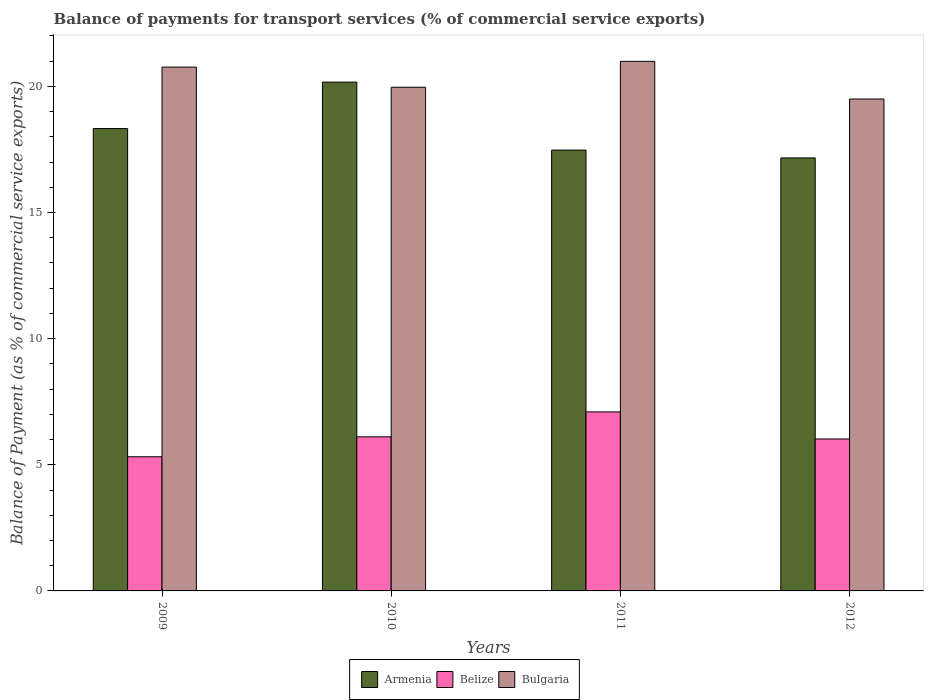How many groups of bars are there?
Provide a succinct answer. 4. What is the label of the 2nd group of bars from the left?
Provide a succinct answer. 2010. In how many cases, is the number of bars for a given year not equal to the number of legend labels?
Your response must be concise. 0. What is the balance of payments for transport services in Armenia in 2012?
Your answer should be compact. 17.16. Across all years, what is the maximum balance of payments for transport services in Bulgaria?
Your answer should be compact. 20.99. Across all years, what is the minimum balance of payments for transport services in Belize?
Make the answer very short. 5.32. In which year was the balance of payments for transport services in Bulgaria minimum?
Your answer should be compact. 2012. What is the total balance of payments for transport services in Bulgaria in the graph?
Your response must be concise. 81.22. What is the difference between the balance of payments for transport services in Armenia in 2011 and that in 2012?
Make the answer very short. 0.31. What is the difference between the balance of payments for transport services in Bulgaria in 2009 and the balance of payments for transport services in Armenia in 2012?
Provide a succinct answer. 3.6. What is the average balance of payments for transport services in Armenia per year?
Offer a terse response. 18.28. In the year 2012, what is the difference between the balance of payments for transport services in Belize and balance of payments for transport services in Armenia?
Give a very brief answer. -11.14. What is the ratio of the balance of payments for transport services in Armenia in 2009 to that in 2011?
Offer a very short reply. 1.05. Is the balance of payments for transport services in Belize in 2009 less than that in 2010?
Your answer should be compact. Yes. What is the difference between the highest and the second highest balance of payments for transport services in Bulgaria?
Provide a succinct answer. 0.23. What is the difference between the highest and the lowest balance of payments for transport services in Armenia?
Ensure brevity in your answer.  3.01. In how many years, is the balance of payments for transport services in Armenia greater than the average balance of payments for transport services in Armenia taken over all years?
Offer a terse response. 2. Is the sum of the balance of payments for transport services in Bulgaria in 2010 and 2011 greater than the maximum balance of payments for transport services in Armenia across all years?
Your answer should be very brief. Yes. What does the 1st bar from the left in 2011 represents?
Offer a terse response. Armenia. What does the 3rd bar from the right in 2010 represents?
Make the answer very short. Armenia. How many bars are there?
Make the answer very short. 12. Are all the bars in the graph horizontal?
Provide a succinct answer. No. Are the values on the major ticks of Y-axis written in scientific E-notation?
Make the answer very short. No. Does the graph contain any zero values?
Offer a very short reply. No. Where does the legend appear in the graph?
Provide a succinct answer. Bottom center. What is the title of the graph?
Give a very brief answer. Balance of payments for transport services (% of commercial service exports). Does "Bahamas" appear as one of the legend labels in the graph?
Your answer should be very brief. No. What is the label or title of the Y-axis?
Provide a succinct answer. Balance of Payment (as % of commercial service exports). What is the Balance of Payment (as % of commercial service exports) in Armenia in 2009?
Provide a succinct answer. 18.33. What is the Balance of Payment (as % of commercial service exports) in Belize in 2009?
Offer a terse response. 5.32. What is the Balance of Payment (as % of commercial service exports) of Bulgaria in 2009?
Your answer should be very brief. 20.76. What is the Balance of Payment (as % of commercial service exports) of Armenia in 2010?
Your response must be concise. 20.17. What is the Balance of Payment (as % of commercial service exports) of Belize in 2010?
Your answer should be compact. 6.11. What is the Balance of Payment (as % of commercial service exports) of Bulgaria in 2010?
Provide a short and direct response. 19.97. What is the Balance of Payment (as % of commercial service exports) in Armenia in 2011?
Give a very brief answer. 17.48. What is the Balance of Payment (as % of commercial service exports) in Belize in 2011?
Ensure brevity in your answer.  7.1. What is the Balance of Payment (as % of commercial service exports) in Bulgaria in 2011?
Ensure brevity in your answer.  20.99. What is the Balance of Payment (as % of commercial service exports) in Armenia in 2012?
Your response must be concise. 17.16. What is the Balance of Payment (as % of commercial service exports) of Belize in 2012?
Provide a succinct answer. 6.02. What is the Balance of Payment (as % of commercial service exports) in Bulgaria in 2012?
Ensure brevity in your answer.  19.5. Across all years, what is the maximum Balance of Payment (as % of commercial service exports) in Armenia?
Your answer should be very brief. 20.17. Across all years, what is the maximum Balance of Payment (as % of commercial service exports) in Belize?
Make the answer very short. 7.1. Across all years, what is the maximum Balance of Payment (as % of commercial service exports) in Bulgaria?
Provide a short and direct response. 20.99. Across all years, what is the minimum Balance of Payment (as % of commercial service exports) of Armenia?
Give a very brief answer. 17.16. Across all years, what is the minimum Balance of Payment (as % of commercial service exports) in Belize?
Provide a short and direct response. 5.32. Across all years, what is the minimum Balance of Payment (as % of commercial service exports) in Bulgaria?
Give a very brief answer. 19.5. What is the total Balance of Payment (as % of commercial service exports) in Armenia in the graph?
Your response must be concise. 73.13. What is the total Balance of Payment (as % of commercial service exports) of Belize in the graph?
Keep it short and to the point. 24.55. What is the total Balance of Payment (as % of commercial service exports) of Bulgaria in the graph?
Keep it short and to the point. 81.22. What is the difference between the Balance of Payment (as % of commercial service exports) of Armenia in 2009 and that in 2010?
Ensure brevity in your answer.  -1.84. What is the difference between the Balance of Payment (as % of commercial service exports) of Belize in 2009 and that in 2010?
Provide a succinct answer. -0.79. What is the difference between the Balance of Payment (as % of commercial service exports) in Bulgaria in 2009 and that in 2010?
Offer a very short reply. 0.8. What is the difference between the Balance of Payment (as % of commercial service exports) of Armenia in 2009 and that in 2011?
Provide a succinct answer. 0.85. What is the difference between the Balance of Payment (as % of commercial service exports) of Belize in 2009 and that in 2011?
Your answer should be compact. -1.78. What is the difference between the Balance of Payment (as % of commercial service exports) in Bulgaria in 2009 and that in 2011?
Provide a short and direct response. -0.23. What is the difference between the Balance of Payment (as % of commercial service exports) of Armenia in 2009 and that in 2012?
Give a very brief answer. 1.16. What is the difference between the Balance of Payment (as % of commercial service exports) in Belize in 2009 and that in 2012?
Offer a terse response. -0.7. What is the difference between the Balance of Payment (as % of commercial service exports) of Bulgaria in 2009 and that in 2012?
Your response must be concise. 1.27. What is the difference between the Balance of Payment (as % of commercial service exports) of Armenia in 2010 and that in 2011?
Provide a short and direct response. 2.69. What is the difference between the Balance of Payment (as % of commercial service exports) in Belize in 2010 and that in 2011?
Your response must be concise. -0.99. What is the difference between the Balance of Payment (as % of commercial service exports) of Bulgaria in 2010 and that in 2011?
Make the answer very short. -1.03. What is the difference between the Balance of Payment (as % of commercial service exports) of Armenia in 2010 and that in 2012?
Offer a very short reply. 3.01. What is the difference between the Balance of Payment (as % of commercial service exports) of Belize in 2010 and that in 2012?
Give a very brief answer. 0.09. What is the difference between the Balance of Payment (as % of commercial service exports) in Bulgaria in 2010 and that in 2012?
Provide a short and direct response. 0.47. What is the difference between the Balance of Payment (as % of commercial service exports) in Armenia in 2011 and that in 2012?
Offer a very short reply. 0.31. What is the difference between the Balance of Payment (as % of commercial service exports) of Belize in 2011 and that in 2012?
Ensure brevity in your answer.  1.07. What is the difference between the Balance of Payment (as % of commercial service exports) in Bulgaria in 2011 and that in 2012?
Give a very brief answer. 1.49. What is the difference between the Balance of Payment (as % of commercial service exports) of Armenia in 2009 and the Balance of Payment (as % of commercial service exports) of Belize in 2010?
Offer a very short reply. 12.22. What is the difference between the Balance of Payment (as % of commercial service exports) in Armenia in 2009 and the Balance of Payment (as % of commercial service exports) in Bulgaria in 2010?
Offer a very short reply. -1.64. What is the difference between the Balance of Payment (as % of commercial service exports) of Belize in 2009 and the Balance of Payment (as % of commercial service exports) of Bulgaria in 2010?
Offer a very short reply. -14.65. What is the difference between the Balance of Payment (as % of commercial service exports) in Armenia in 2009 and the Balance of Payment (as % of commercial service exports) in Belize in 2011?
Your answer should be compact. 11.23. What is the difference between the Balance of Payment (as % of commercial service exports) in Armenia in 2009 and the Balance of Payment (as % of commercial service exports) in Bulgaria in 2011?
Provide a succinct answer. -2.67. What is the difference between the Balance of Payment (as % of commercial service exports) of Belize in 2009 and the Balance of Payment (as % of commercial service exports) of Bulgaria in 2011?
Your answer should be very brief. -15.67. What is the difference between the Balance of Payment (as % of commercial service exports) in Armenia in 2009 and the Balance of Payment (as % of commercial service exports) in Belize in 2012?
Give a very brief answer. 12.3. What is the difference between the Balance of Payment (as % of commercial service exports) of Armenia in 2009 and the Balance of Payment (as % of commercial service exports) of Bulgaria in 2012?
Offer a very short reply. -1.17. What is the difference between the Balance of Payment (as % of commercial service exports) of Belize in 2009 and the Balance of Payment (as % of commercial service exports) of Bulgaria in 2012?
Provide a succinct answer. -14.18. What is the difference between the Balance of Payment (as % of commercial service exports) of Armenia in 2010 and the Balance of Payment (as % of commercial service exports) of Belize in 2011?
Your answer should be compact. 13.07. What is the difference between the Balance of Payment (as % of commercial service exports) in Armenia in 2010 and the Balance of Payment (as % of commercial service exports) in Bulgaria in 2011?
Provide a short and direct response. -0.82. What is the difference between the Balance of Payment (as % of commercial service exports) of Belize in 2010 and the Balance of Payment (as % of commercial service exports) of Bulgaria in 2011?
Ensure brevity in your answer.  -14.88. What is the difference between the Balance of Payment (as % of commercial service exports) in Armenia in 2010 and the Balance of Payment (as % of commercial service exports) in Belize in 2012?
Your answer should be very brief. 14.15. What is the difference between the Balance of Payment (as % of commercial service exports) in Armenia in 2010 and the Balance of Payment (as % of commercial service exports) in Bulgaria in 2012?
Ensure brevity in your answer.  0.67. What is the difference between the Balance of Payment (as % of commercial service exports) in Belize in 2010 and the Balance of Payment (as % of commercial service exports) in Bulgaria in 2012?
Your answer should be compact. -13.39. What is the difference between the Balance of Payment (as % of commercial service exports) of Armenia in 2011 and the Balance of Payment (as % of commercial service exports) of Belize in 2012?
Offer a very short reply. 11.45. What is the difference between the Balance of Payment (as % of commercial service exports) in Armenia in 2011 and the Balance of Payment (as % of commercial service exports) in Bulgaria in 2012?
Your response must be concise. -2.02. What is the difference between the Balance of Payment (as % of commercial service exports) of Belize in 2011 and the Balance of Payment (as % of commercial service exports) of Bulgaria in 2012?
Give a very brief answer. -12.4. What is the average Balance of Payment (as % of commercial service exports) of Armenia per year?
Give a very brief answer. 18.28. What is the average Balance of Payment (as % of commercial service exports) of Belize per year?
Provide a short and direct response. 6.14. What is the average Balance of Payment (as % of commercial service exports) of Bulgaria per year?
Ensure brevity in your answer.  20.31. In the year 2009, what is the difference between the Balance of Payment (as % of commercial service exports) in Armenia and Balance of Payment (as % of commercial service exports) in Belize?
Make the answer very short. 13.01. In the year 2009, what is the difference between the Balance of Payment (as % of commercial service exports) of Armenia and Balance of Payment (as % of commercial service exports) of Bulgaria?
Offer a terse response. -2.44. In the year 2009, what is the difference between the Balance of Payment (as % of commercial service exports) in Belize and Balance of Payment (as % of commercial service exports) in Bulgaria?
Provide a succinct answer. -15.45. In the year 2010, what is the difference between the Balance of Payment (as % of commercial service exports) in Armenia and Balance of Payment (as % of commercial service exports) in Belize?
Your answer should be compact. 14.06. In the year 2010, what is the difference between the Balance of Payment (as % of commercial service exports) of Armenia and Balance of Payment (as % of commercial service exports) of Bulgaria?
Your response must be concise. 0.2. In the year 2010, what is the difference between the Balance of Payment (as % of commercial service exports) in Belize and Balance of Payment (as % of commercial service exports) in Bulgaria?
Your response must be concise. -13.86. In the year 2011, what is the difference between the Balance of Payment (as % of commercial service exports) of Armenia and Balance of Payment (as % of commercial service exports) of Belize?
Offer a terse response. 10.38. In the year 2011, what is the difference between the Balance of Payment (as % of commercial service exports) of Armenia and Balance of Payment (as % of commercial service exports) of Bulgaria?
Offer a very short reply. -3.52. In the year 2011, what is the difference between the Balance of Payment (as % of commercial service exports) of Belize and Balance of Payment (as % of commercial service exports) of Bulgaria?
Your answer should be very brief. -13.9. In the year 2012, what is the difference between the Balance of Payment (as % of commercial service exports) of Armenia and Balance of Payment (as % of commercial service exports) of Belize?
Your answer should be very brief. 11.14. In the year 2012, what is the difference between the Balance of Payment (as % of commercial service exports) of Armenia and Balance of Payment (as % of commercial service exports) of Bulgaria?
Your answer should be very brief. -2.34. In the year 2012, what is the difference between the Balance of Payment (as % of commercial service exports) in Belize and Balance of Payment (as % of commercial service exports) in Bulgaria?
Your answer should be very brief. -13.48. What is the ratio of the Balance of Payment (as % of commercial service exports) in Armenia in 2009 to that in 2010?
Offer a very short reply. 0.91. What is the ratio of the Balance of Payment (as % of commercial service exports) of Belize in 2009 to that in 2010?
Offer a very short reply. 0.87. What is the ratio of the Balance of Payment (as % of commercial service exports) of Armenia in 2009 to that in 2011?
Offer a terse response. 1.05. What is the ratio of the Balance of Payment (as % of commercial service exports) in Belize in 2009 to that in 2011?
Offer a very short reply. 0.75. What is the ratio of the Balance of Payment (as % of commercial service exports) in Armenia in 2009 to that in 2012?
Your answer should be compact. 1.07. What is the ratio of the Balance of Payment (as % of commercial service exports) in Belize in 2009 to that in 2012?
Offer a very short reply. 0.88. What is the ratio of the Balance of Payment (as % of commercial service exports) in Bulgaria in 2009 to that in 2012?
Your answer should be very brief. 1.06. What is the ratio of the Balance of Payment (as % of commercial service exports) in Armenia in 2010 to that in 2011?
Offer a very short reply. 1.15. What is the ratio of the Balance of Payment (as % of commercial service exports) of Belize in 2010 to that in 2011?
Your answer should be compact. 0.86. What is the ratio of the Balance of Payment (as % of commercial service exports) of Bulgaria in 2010 to that in 2011?
Offer a very short reply. 0.95. What is the ratio of the Balance of Payment (as % of commercial service exports) of Armenia in 2010 to that in 2012?
Ensure brevity in your answer.  1.18. What is the ratio of the Balance of Payment (as % of commercial service exports) in Belize in 2010 to that in 2012?
Keep it short and to the point. 1.01. What is the ratio of the Balance of Payment (as % of commercial service exports) of Bulgaria in 2010 to that in 2012?
Your response must be concise. 1.02. What is the ratio of the Balance of Payment (as % of commercial service exports) of Armenia in 2011 to that in 2012?
Provide a short and direct response. 1.02. What is the ratio of the Balance of Payment (as % of commercial service exports) in Belize in 2011 to that in 2012?
Your response must be concise. 1.18. What is the ratio of the Balance of Payment (as % of commercial service exports) in Bulgaria in 2011 to that in 2012?
Give a very brief answer. 1.08. What is the difference between the highest and the second highest Balance of Payment (as % of commercial service exports) of Armenia?
Your answer should be compact. 1.84. What is the difference between the highest and the second highest Balance of Payment (as % of commercial service exports) in Belize?
Keep it short and to the point. 0.99. What is the difference between the highest and the second highest Balance of Payment (as % of commercial service exports) in Bulgaria?
Give a very brief answer. 0.23. What is the difference between the highest and the lowest Balance of Payment (as % of commercial service exports) in Armenia?
Give a very brief answer. 3.01. What is the difference between the highest and the lowest Balance of Payment (as % of commercial service exports) of Belize?
Keep it short and to the point. 1.78. What is the difference between the highest and the lowest Balance of Payment (as % of commercial service exports) of Bulgaria?
Your answer should be compact. 1.49. 